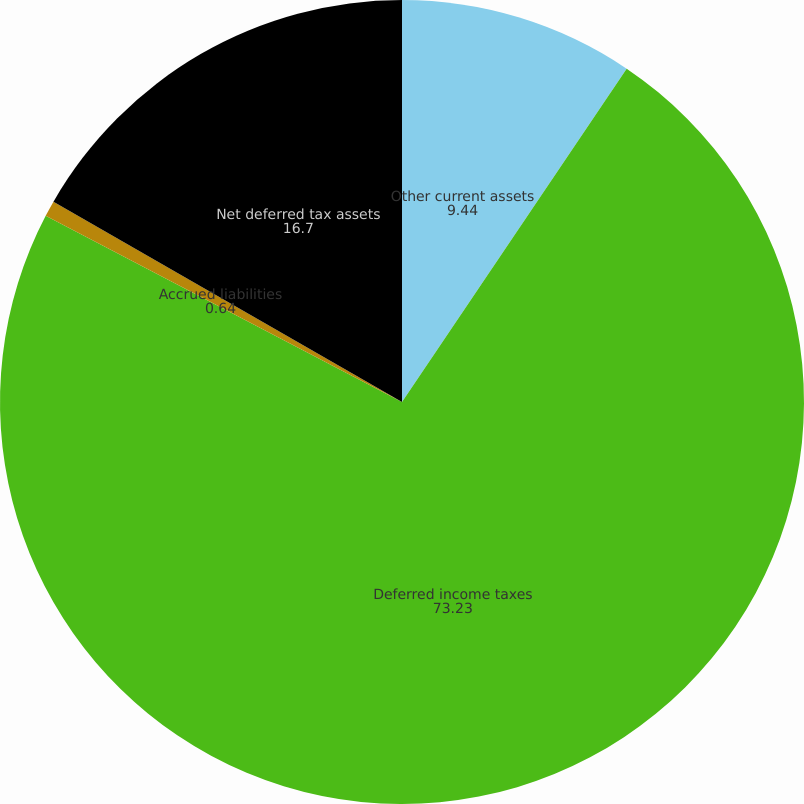Convert chart to OTSL. <chart><loc_0><loc_0><loc_500><loc_500><pie_chart><fcel>Other current assets<fcel>Deferred income taxes<fcel>Accrued liabilities<fcel>Net deferred tax assets<nl><fcel>9.44%<fcel>73.23%<fcel>0.64%<fcel>16.7%<nl></chart> 